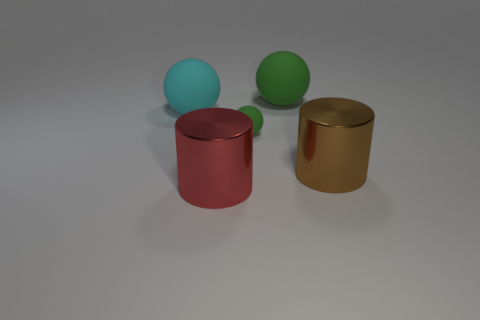Add 4 big cyan cubes. How many objects exist? 9 Subtract all cylinders. How many objects are left? 3 Add 4 tiny green balls. How many tiny green balls exist? 5 Subtract 0 gray blocks. How many objects are left? 5 Subtract all small brown metallic things. Subtract all large brown metal cylinders. How many objects are left? 4 Add 3 brown metal objects. How many brown metal objects are left? 4 